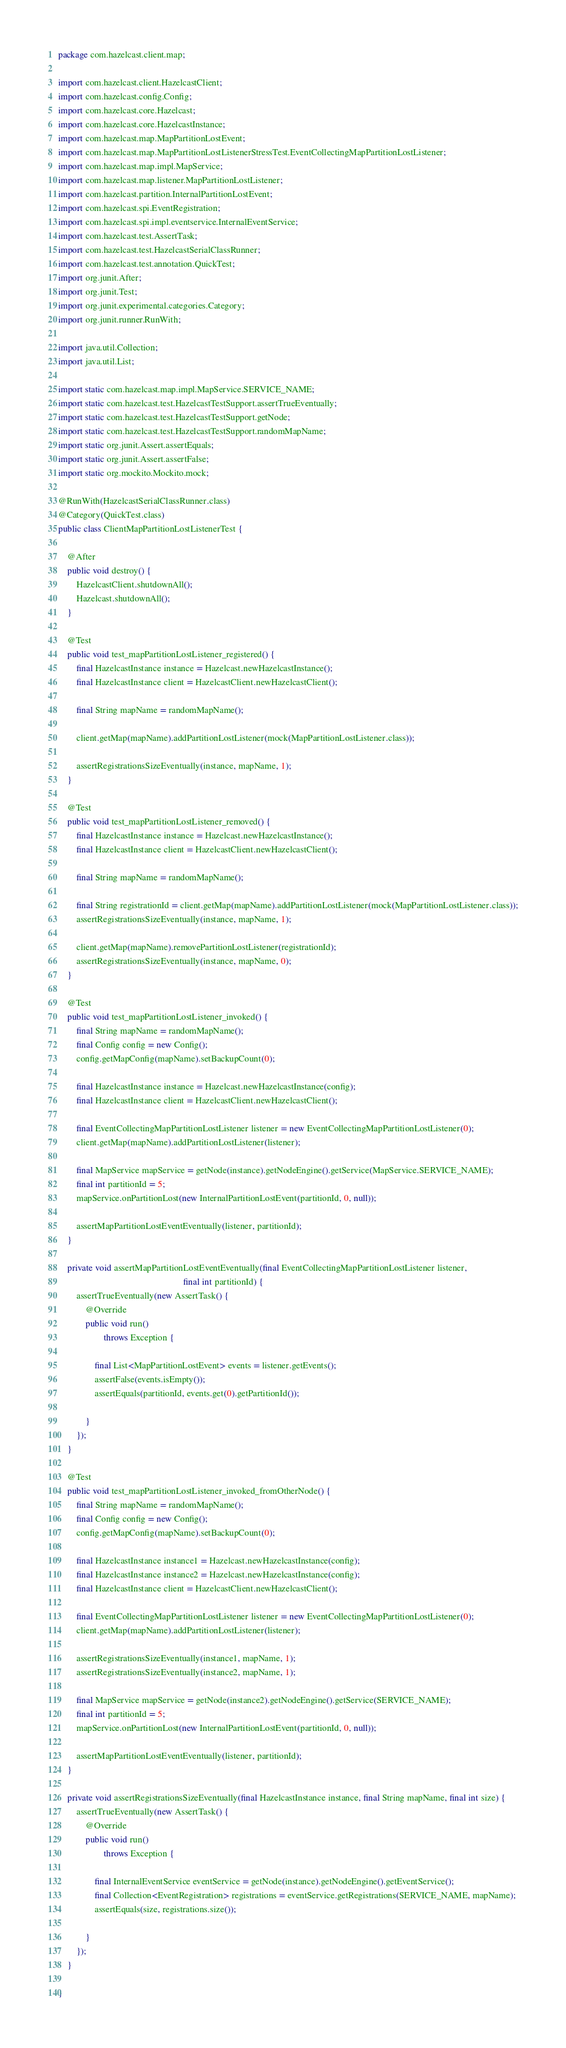Convert code to text. <code><loc_0><loc_0><loc_500><loc_500><_Java_>package com.hazelcast.client.map;

import com.hazelcast.client.HazelcastClient;
import com.hazelcast.config.Config;
import com.hazelcast.core.Hazelcast;
import com.hazelcast.core.HazelcastInstance;
import com.hazelcast.map.MapPartitionLostEvent;
import com.hazelcast.map.MapPartitionLostListenerStressTest.EventCollectingMapPartitionLostListener;
import com.hazelcast.map.impl.MapService;
import com.hazelcast.map.listener.MapPartitionLostListener;
import com.hazelcast.partition.InternalPartitionLostEvent;
import com.hazelcast.spi.EventRegistration;
import com.hazelcast.spi.impl.eventservice.InternalEventService;
import com.hazelcast.test.AssertTask;
import com.hazelcast.test.HazelcastSerialClassRunner;
import com.hazelcast.test.annotation.QuickTest;
import org.junit.After;
import org.junit.Test;
import org.junit.experimental.categories.Category;
import org.junit.runner.RunWith;

import java.util.Collection;
import java.util.List;

import static com.hazelcast.map.impl.MapService.SERVICE_NAME;
import static com.hazelcast.test.HazelcastTestSupport.assertTrueEventually;
import static com.hazelcast.test.HazelcastTestSupport.getNode;
import static com.hazelcast.test.HazelcastTestSupport.randomMapName;
import static org.junit.Assert.assertEquals;
import static org.junit.Assert.assertFalse;
import static org.mockito.Mockito.mock;

@RunWith(HazelcastSerialClassRunner.class)
@Category(QuickTest.class)
public class ClientMapPartitionLostListenerTest {

    @After
    public void destroy() {
        HazelcastClient.shutdownAll();
        Hazelcast.shutdownAll();
    }

    @Test
    public void test_mapPartitionLostListener_registered() {
        final HazelcastInstance instance = Hazelcast.newHazelcastInstance();
        final HazelcastInstance client = HazelcastClient.newHazelcastClient();

        final String mapName = randomMapName();

        client.getMap(mapName).addPartitionLostListener(mock(MapPartitionLostListener.class));

        assertRegistrationsSizeEventually(instance, mapName, 1);
    }

    @Test
    public void test_mapPartitionLostListener_removed() {
        final HazelcastInstance instance = Hazelcast.newHazelcastInstance();
        final HazelcastInstance client = HazelcastClient.newHazelcastClient();

        final String mapName = randomMapName();

        final String registrationId = client.getMap(mapName).addPartitionLostListener(mock(MapPartitionLostListener.class));
        assertRegistrationsSizeEventually(instance, mapName, 1);

        client.getMap(mapName).removePartitionLostListener(registrationId);
        assertRegistrationsSizeEventually(instance, mapName, 0);
    }

    @Test
    public void test_mapPartitionLostListener_invoked() {
        final String mapName = randomMapName();
        final Config config = new Config();
        config.getMapConfig(mapName).setBackupCount(0);

        final HazelcastInstance instance = Hazelcast.newHazelcastInstance(config);
        final HazelcastInstance client = HazelcastClient.newHazelcastClient();

        final EventCollectingMapPartitionLostListener listener = new EventCollectingMapPartitionLostListener(0);
        client.getMap(mapName).addPartitionLostListener(listener);

        final MapService mapService = getNode(instance).getNodeEngine().getService(MapService.SERVICE_NAME);
        final int partitionId = 5;
        mapService.onPartitionLost(new InternalPartitionLostEvent(partitionId, 0, null));

        assertMapPartitionLostEventEventually(listener, partitionId);
    }

    private void assertMapPartitionLostEventEventually(final EventCollectingMapPartitionLostListener listener,
                                                       final int partitionId) {
        assertTrueEventually(new AssertTask() {
            @Override
            public void run()
                    throws Exception {

                final List<MapPartitionLostEvent> events = listener.getEvents();
                assertFalse(events.isEmpty());
                assertEquals(partitionId, events.get(0).getPartitionId());

            }
        });
    }

    @Test
    public void test_mapPartitionLostListener_invoked_fromOtherNode() {
        final String mapName = randomMapName();
        final Config config = new Config();
        config.getMapConfig(mapName).setBackupCount(0);

        final HazelcastInstance instance1 = Hazelcast.newHazelcastInstance(config);
        final HazelcastInstance instance2 = Hazelcast.newHazelcastInstance(config);
        final HazelcastInstance client = HazelcastClient.newHazelcastClient();

        final EventCollectingMapPartitionLostListener listener = new EventCollectingMapPartitionLostListener(0);
        client.getMap(mapName).addPartitionLostListener(listener);

        assertRegistrationsSizeEventually(instance1, mapName, 1);
        assertRegistrationsSizeEventually(instance2, mapName, 1);

        final MapService mapService = getNode(instance2).getNodeEngine().getService(SERVICE_NAME);
        final int partitionId = 5;
        mapService.onPartitionLost(new InternalPartitionLostEvent(partitionId, 0, null));

        assertMapPartitionLostEventEventually(listener, partitionId);
    }

    private void assertRegistrationsSizeEventually(final HazelcastInstance instance, final String mapName, final int size) {
        assertTrueEventually(new AssertTask() {
            @Override
            public void run()
                    throws Exception {

                final InternalEventService eventService = getNode(instance).getNodeEngine().getEventService();
                final Collection<EventRegistration> registrations = eventService.getRegistrations(SERVICE_NAME, mapName);
                assertEquals(size, registrations.size());

            }
        });
    }

}
</code> 